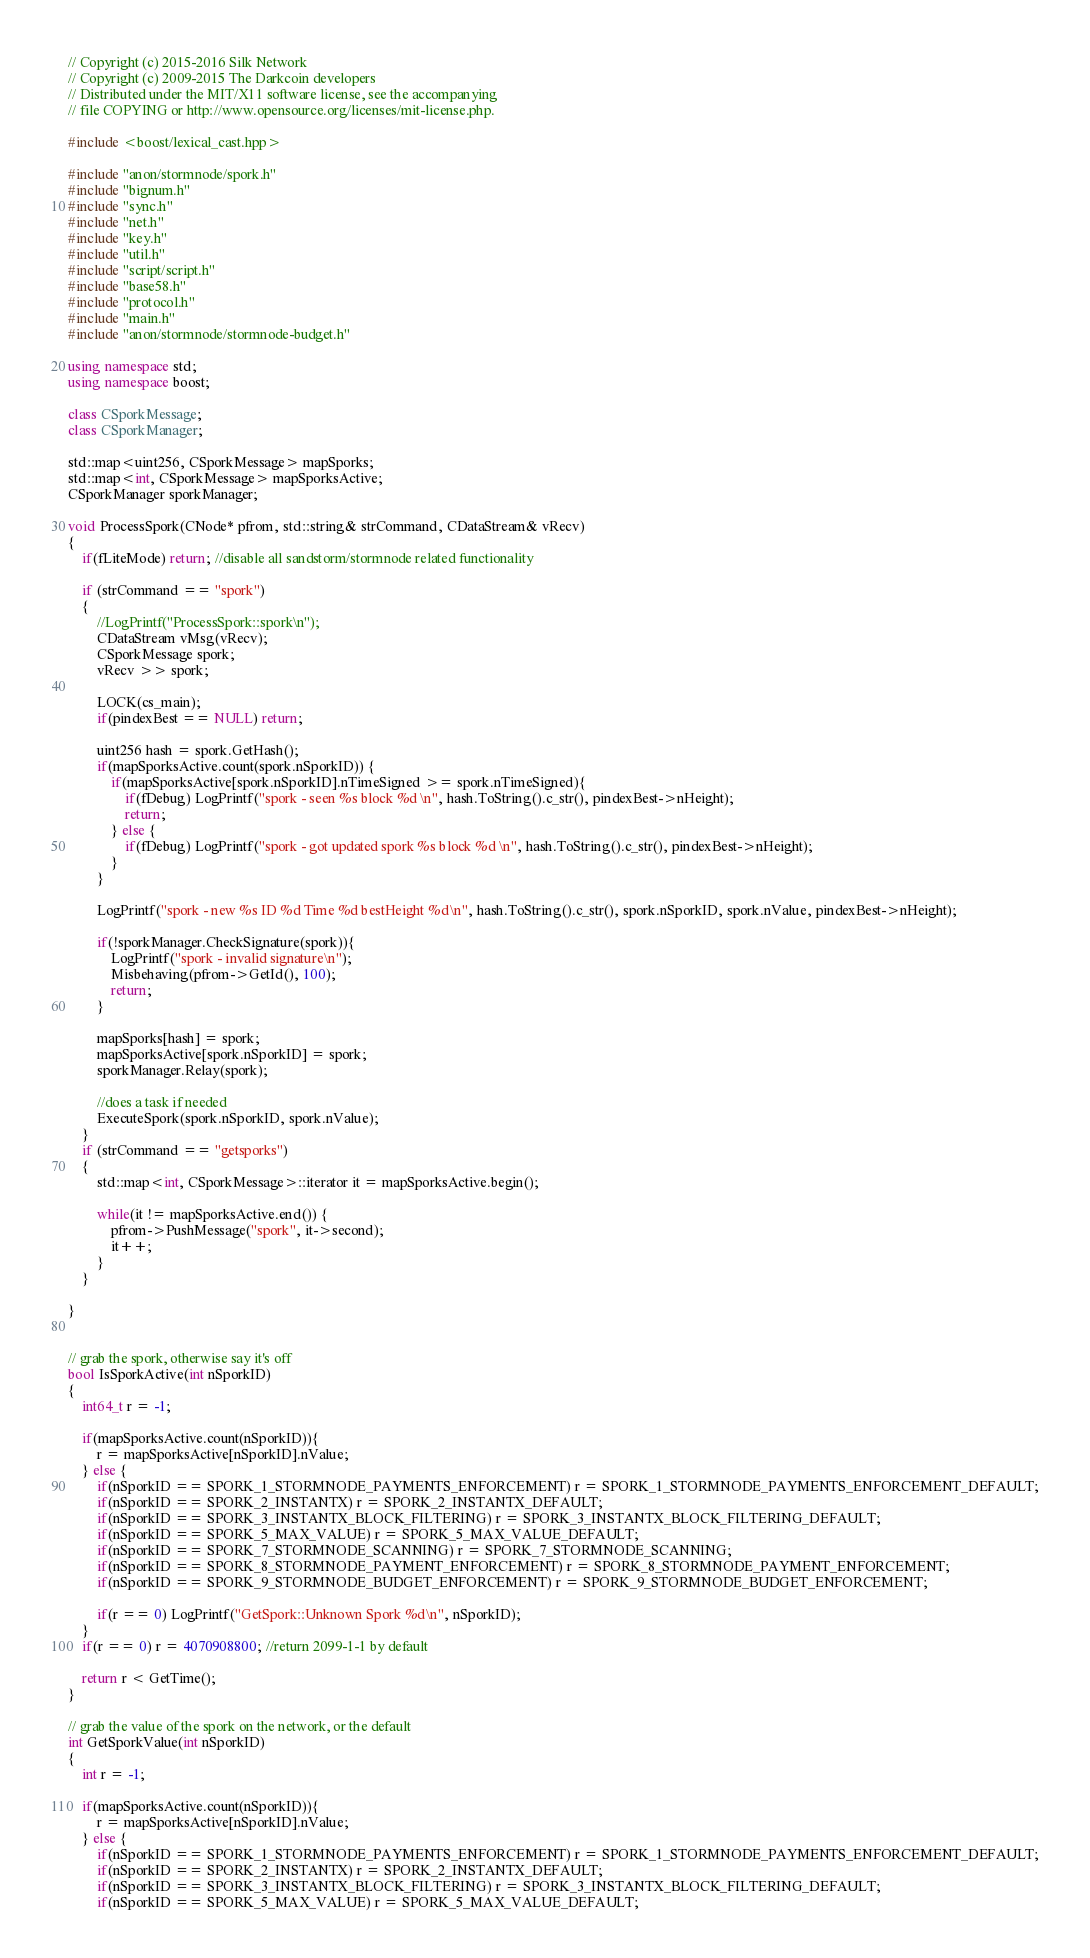Convert code to text. <code><loc_0><loc_0><loc_500><loc_500><_C++_>// Copyright (c) 2015-2016 Silk Network
// Copyright (c) 2009-2015 The Darkcoin developers
// Distributed under the MIT/X11 software license, see the accompanying
// file COPYING or http://www.opensource.org/licenses/mit-license.php.

#include <boost/lexical_cast.hpp>

#include "anon/stormnode/spork.h"
#include "bignum.h"
#include "sync.h"
#include "net.h"
#include "key.h"
#include "util.h"
#include "script/script.h"
#include "base58.h"
#include "protocol.h"
#include "main.h"
#include "anon/stormnode/stormnode-budget.h"

using namespace std;
using namespace boost;

class CSporkMessage;
class CSporkManager;

std::map<uint256, CSporkMessage> mapSporks;
std::map<int, CSporkMessage> mapSporksActive;
CSporkManager sporkManager;

void ProcessSpork(CNode* pfrom, std::string& strCommand, CDataStream& vRecv)
{
    if(fLiteMode) return; //disable all sandstorm/stormnode related functionality

    if (strCommand == "spork")
    {
        //LogPrintf("ProcessSpork::spork\n");
        CDataStream vMsg(vRecv);
        CSporkMessage spork;
        vRecv >> spork;

        LOCK(cs_main);
        if(pindexBest == NULL) return;

        uint256 hash = spork.GetHash();
        if(mapSporksActive.count(spork.nSporkID)) {
            if(mapSporksActive[spork.nSporkID].nTimeSigned >= spork.nTimeSigned){
                if(fDebug) LogPrintf("spork - seen %s block %d \n", hash.ToString().c_str(), pindexBest->nHeight);
                return;
            } else {
                if(fDebug) LogPrintf("spork - got updated spork %s block %d \n", hash.ToString().c_str(), pindexBest->nHeight);
            }
        }

        LogPrintf("spork - new %s ID %d Time %d bestHeight %d\n", hash.ToString().c_str(), spork.nSporkID, spork.nValue, pindexBest->nHeight);

        if(!sporkManager.CheckSignature(spork)){
            LogPrintf("spork - invalid signature\n");
            Misbehaving(pfrom->GetId(), 100);
            return;
        }

        mapSporks[hash] = spork;
        mapSporksActive[spork.nSporkID] = spork;
        sporkManager.Relay(spork);

        //does a task if needed
        ExecuteSpork(spork.nSporkID, spork.nValue);
    }
    if (strCommand == "getsporks")
    {
        std::map<int, CSporkMessage>::iterator it = mapSporksActive.begin();

        while(it != mapSporksActive.end()) {
            pfrom->PushMessage("spork", it->second);
            it++;
        }
    }

}


// grab the spork, otherwise say it's off
bool IsSporkActive(int nSporkID)
{
    int64_t r = -1;

    if(mapSporksActive.count(nSporkID)){
        r = mapSporksActive[nSporkID].nValue;
    } else {
        if(nSporkID == SPORK_1_STORMNODE_PAYMENTS_ENFORCEMENT) r = SPORK_1_STORMNODE_PAYMENTS_ENFORCEMENT_DEFAULT;
        if(nSporkID == SPORK_2_INSTANTX) r = SPORK_2_INSTANTX_DEFAULT;
        if(nSporkID == SPORK_3_INSTANTX_BLOCK_FILTERING) r = SPORK_3_INSTANTX_BLOCK_FILTERING_DEFAULT;
        if(nSporkID == SPORK_5_MAX_VALUE) r = SPORK_5_MAX_VALUE_DEFAULT;
        if(nSporkID == SPORK_7_STORMNODE_SCANNING) r = SPORK_7_STORMNODE_SCANNING;
        if(nSporkID == SPORK_8_STORMNODE_PAYMENT_ENFORCEMENT) r = SPORK_8_STORMNODE_PAYMENT_ENFORCEMENT;
        if(nSporkID == SPORK_9_STORMNODE_BUDGET_ENFORCEMENT) r = SPORK_9_STORMNODE_BUDGET_ENFORCEMENT;

        if(r == 0) LogPrintf("GetSpork::Unknown Spork %d\n", nSporkID);
    }
    if(r == 0) r = 4070908800; //return 2099-1-1 by default

    return r < GetTime();
}

// grab the value of the spork on the network, or the default
int GetSporkValue(int nSporkID)
{
    int r = -1;

    if(mapSporksActive.count(nSporkID)){
        r = mapSporksActive[nSporkID].nValue;
    } else {
        if(nSporkID == SPORK_1_STORMNODE_PAYMENTS_ENFORCEMENT) r = SPORK_1_STORMNODE_PAYMENTS_ENFORCEMENT_DEFAULT;
        if(nSporkID == SPORK_2_INSTANTX) r = SPORK_2_INSTANTX_DEFAULT;
        if(nSporkID == SPORK_3_INSTANTX_BLOCK_FILTERING) r = SPORK_3_INSTANTX_BLOCK_FILTERING_DEFAULT;
        if(nSporkID == SPORK_5_MAX_VALUE) r = SPORK_5_MAX_VALUE_DEFAULT;</code> 